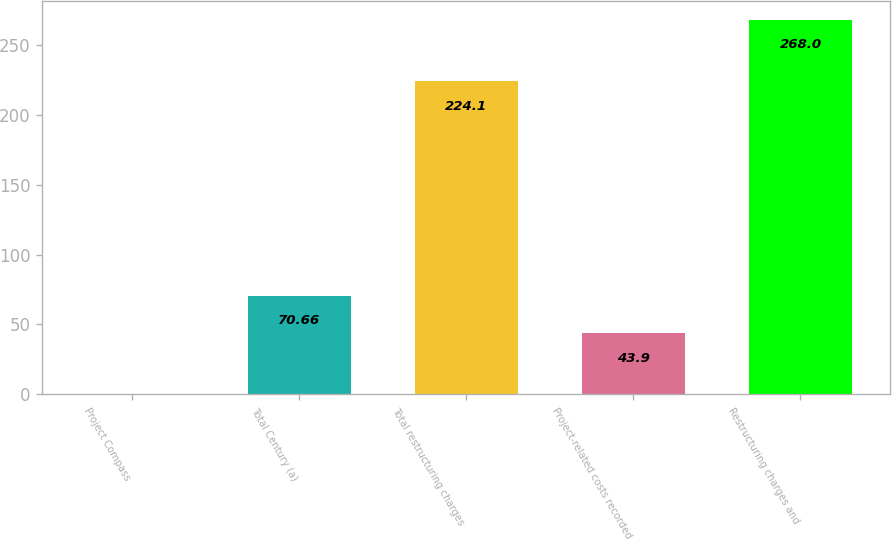Convert chart to OTSL. <chart><loc_0><loc_0><loc_500><loc_500><bar_chart><fcel>Project Compass<fcel>Total Century (a)<fcel>Total restructuring charges<fcel>Project-related costs recorded<fcel>Restructuring charges and<nl><fcel>0.4<fcel>70.66<fcel>224.1<fcel>43.9<fcel>268<nl></chart> 